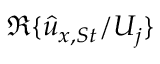Convert formula to latex. <formula><loc_0><loc_0><loc_500><loc_500>\mathfrak { R } \{ \hat { u } _ { x , S t } / U _ { j } \}</formula> 